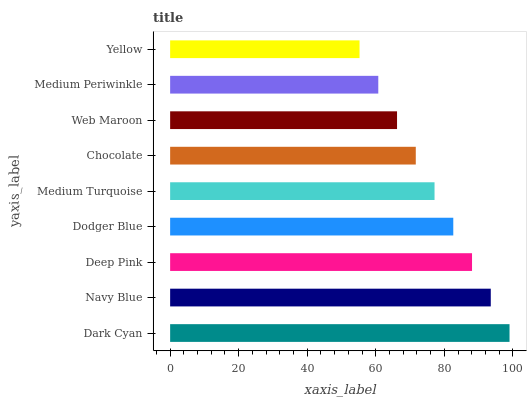Is Yellow the minimum?
Answer yes or no. Yes. Is Dark Cyan the maximum?
Answer yes or no. Yes. Is Navy Blue the minimum?
Answer yes or no. No. Is Navy Blue the maximum?
Answer yes or no. No. Is Dark Cyan greater than Navy Blue?
Answer yes or no. Yes. Is Navy Blue less than Dark Cyan?
Answer yes or no. Yes. Is Navy Blue greater than Dark Cyan?
Answer yes or no. No. Is Dark Cyan less than Navy Blue?
Answer yes or no. No. Is Medium Turquoise the high median?
Answer yes or no. Yes. Is Medium Turquoise the low median?
Answer yes or no. Yes. Is Navy Blue the high median?
Answer yes or no. No. Is Web Maroon the low median?
Answer yes or no. No. 